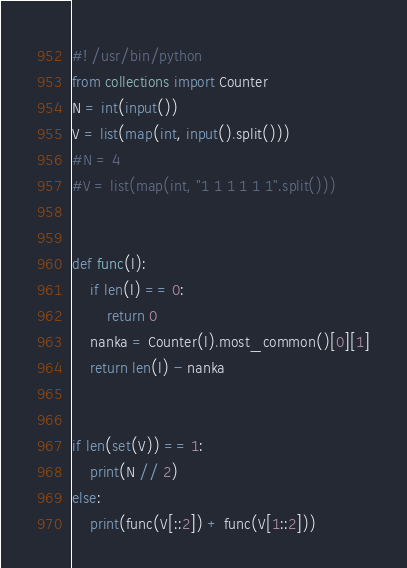<code> <loc_0><loc_0><loc_500><loc_500><_Python_>#! /usr/bin/python
from collections import Counter
N = int(input())
V = list(map(int, input().split()))
#N = 4
#V = list(map(int, "1 1 1 1 1 1".split()))


def func(l):
    if len(l) == 0:
        return 0
    nanka = Counter(l).most_common()[0][1]
    return len(l) - nanka


if len(set(V)) == 1:
    print(N // 2)
else:
    print(func(V[::2]) + func(V[1::2]))
</code> 